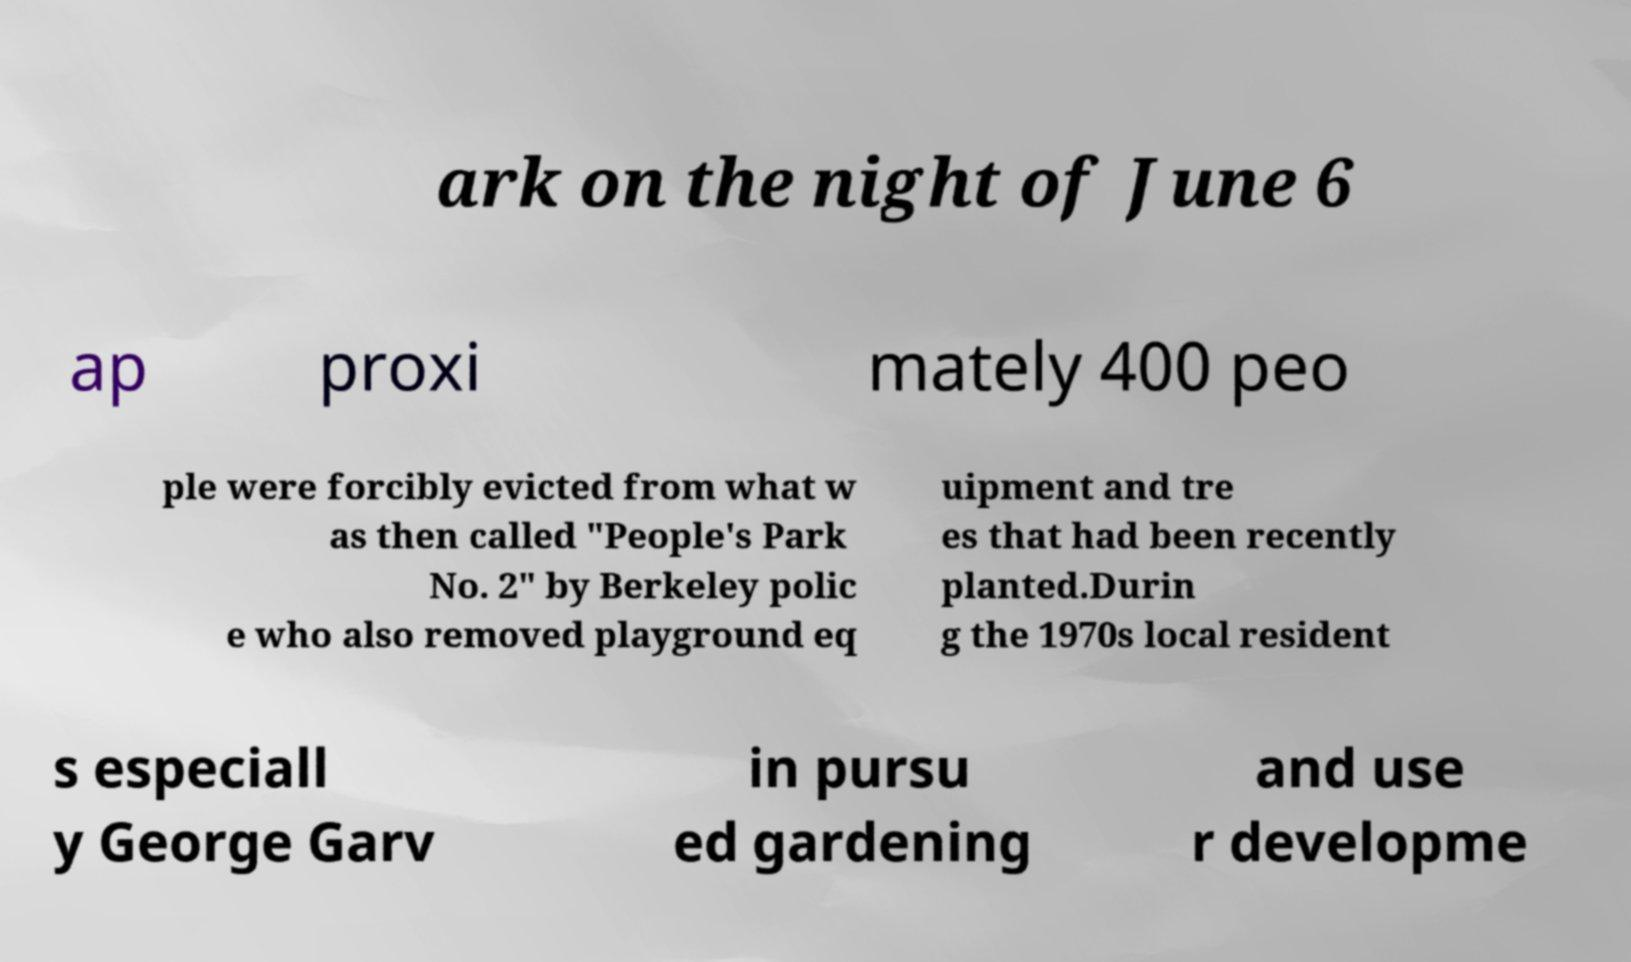For documentation purposes, I need the text within this image transcribed. Could you provide that? ark on the night of June 6 ap proxi mately 400 peo ple were forcibly evicted from what w as then called "People's Park No. 2" by Berkeley polic e who also removed playground eq uipment and tre es that had been recently planted.Durin g the 1970s local resident s especiall y George Garv in pursu ed gardening and use r developme 